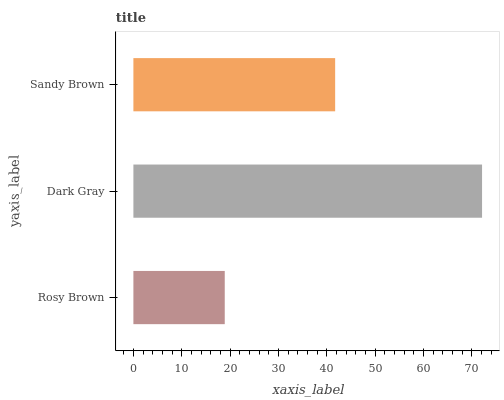Is Rosy Brown the minimum?
Answer yes or no. Yes. Is Dark Gray the maximum?
Answer yes or no. Yes. Is Sandy Brown the minimum?
Answer yes or no. No. Is Sandy Brown the maximum?
Answer yes or no. No. Is Dark Gray greater than Sandy Brown?
Answer yes or no. Yes. Is Sandy Brown less than Dark Gray?
Answer yes or no. Yes. Is Sandy Brown greater than Dark Gray?
Answer yes or no. No. Is Dark Gray less than Sandy Brown?
Answer yes or no. No. Is Sandy Brown the high median?
Answer yes or no. Yes. Is Sandy Brown the low median?
Answer yes or no. Yes. Is Dark Gray the high median?
Answer yes or no. No. Is Dark Gray the low median?
Answer yes or no. No. 